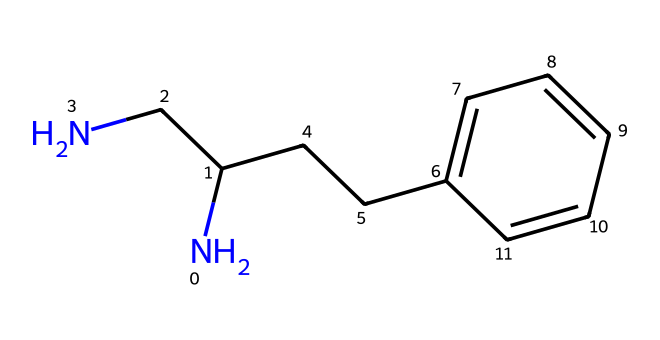What is the molecular formula of this chemical? To find the molecular formula, count the number of each type of atom present in the chemical structure. This chemical has 17 carbon (C) atoms, 18 hydrogen (H) atoms, and 1 nitrogen (N) atom, giving the formula C17H18N.
Answer: C17H18N How many rings are present in the structure of this drug? The structure reveals two distinct rings, which can be identified by the attached double bonds between carbon atoms. Counting these gives two rings in total.
Answer: 2 Is this chemical a first-generation or second-generation antihistamine? By examining the structure, the presence of sedative properties is often associated with first-generation antihistamines such as Diphenhydramine, which this chemical resembles.
Answer: first-generation Which part of the chemical is responsible for antihistamine activity? The ethylamine side chain (specifically the nitrogen in the side chain) is crucial for the antihistamine activity by blocking histamine receptors.
Answer: ethylamine side chain How many oxygen atoms are in this chemical's structure? Inspecting the structure reveals that there are two oxygen (O) atoms present, one is part of an ether functional group and the other is implied in the broader framework of the compound.
Answer: 2 Does this chemical contain any functional groups? If so, name one. Evaluating the structure shows the presence of an ether group due to the presence of an oxygen connected to two carbon chains, indicating the functional group type.
Answer: ether group 